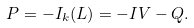<formula> <loc_0><loc_0><loc_500><loc_500>P = - I _ { k } ( L ) = - I V - Q .</formula> 